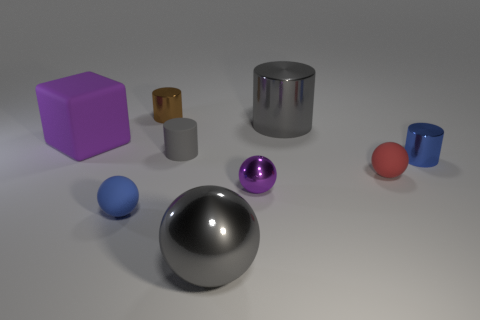The matte object that is behind the purple ball and left of the rubber cylinder has what shape?
Your answer should be very brief. Cube. The object that is both in front of the purple sphere and to the left of the small brown metal thing is what color?
Offer a very short reply. Blue. What number of other things are the same material as the cube?
Your answer should be very brief. 3. Is the number of tiny shiny cylinders less than the number of metallic cylinders?
Offer a very short reply. Yes. Do the big cylinder and the tiny thing that is in front of the tiny metallic ball have the same material?
Your answer should be very brief. No. There is a tiny rubber object that is right of the big gray metal ball; what shape is it?
Your response must be concise. Sphere. Is there anything else that has the same color as the tiny shiny sphere?
Offer a very short reply. Yes. Is the number of small brown objects behind the brown shiny cylinder less than the number of large green cubes?
Offer a terse response. No. What number of matte cylinders are the same size as the blue metal object?
Offer a terse response. 1. What shape is the tiny thing that is the same color as the big cube?
Give a very brief answer. Sphere. 